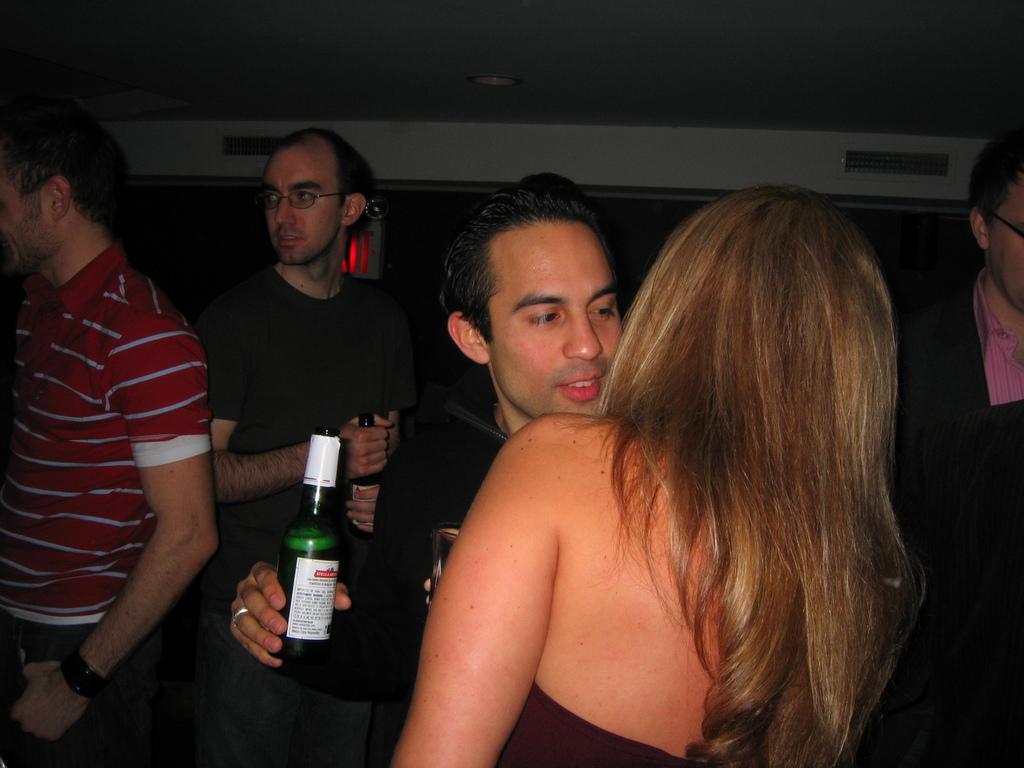Can you describe this image briefly? In this image I can see few people are standing and here I can see few of them are holding bottles. 